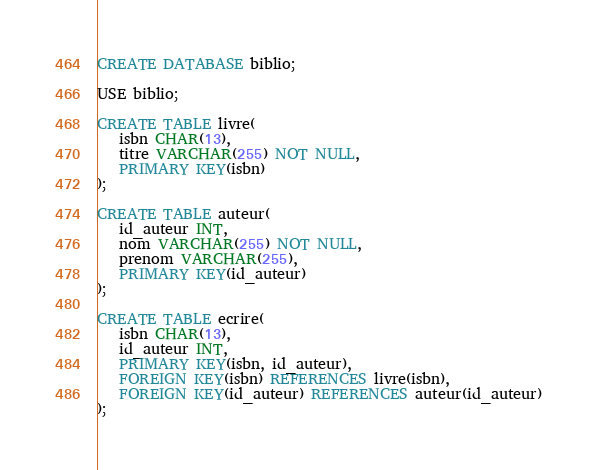Convert code to text. <code><loc_0><loc_0><loc_500><loc_500><_SQL_>CREATE DATABASE biblio;

USE biblio;

CREATE TABLE livre(
   isbn CHAR(13),
   titre VARCHAR(255) NOT NULL,
   PRIMARY KEY(isbn)
);

CREATE TABLE auteur(
   id_auteur INT,
   nom VARCHAR(255) NOT NULL,
   prenom VARCHAR(255),
   PRIMARY KEY(id_auteur)
);

CREATE TABLE ecrire(
   isbn CHAR(13),
   id_auteur INT,
   PRIMARY KEY(isbn, id_auteur),
   FOREIGN KEY(isbn) REFERENCES livre(isbn),
   FOREIGN KEY(id_auteur) REFERENCES auteur(id_auteur)
);
</code> 